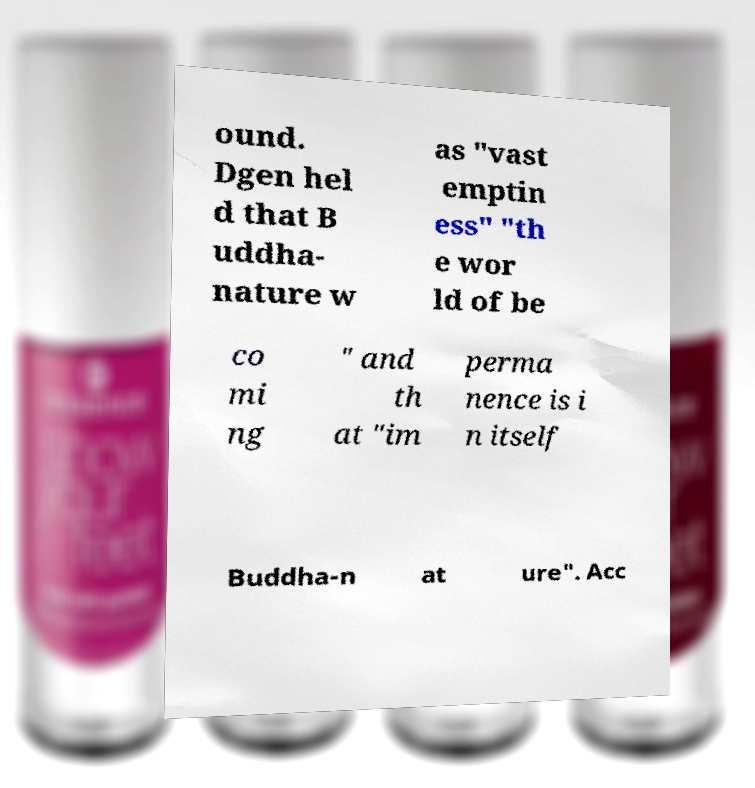Can you accurately transcribe the text from the provided image for me? ound. Dgen hel d that B uddha- nature w as "vast emptin ess" "th e wor ld of be co mi ng " and th at "im perma nence is i n itself Buddha-n at ure". Acc 